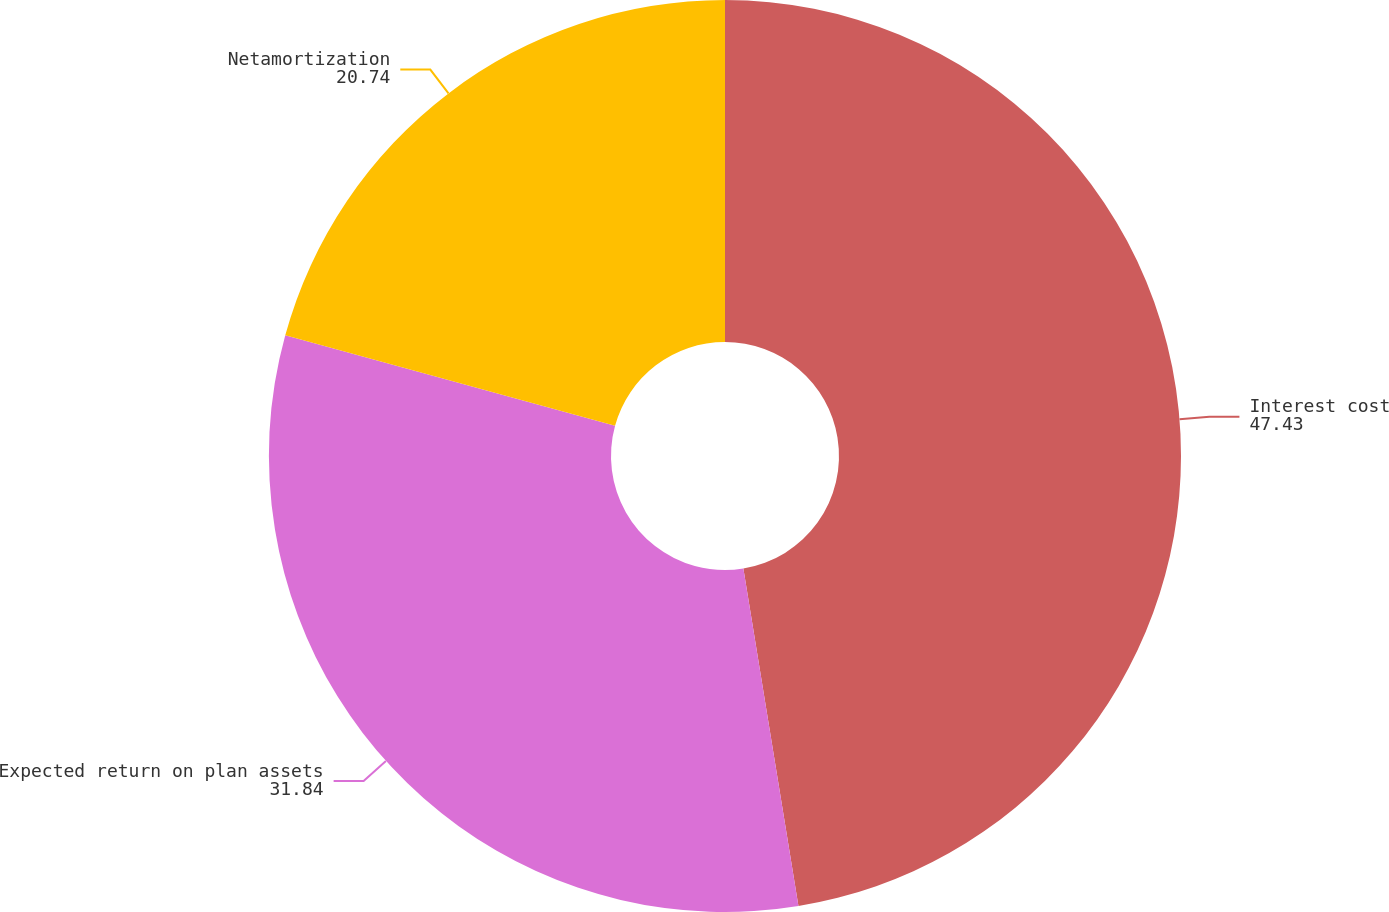<chart> <loc_0><loc_0><loc_500><loc_500><pie_chart><fcel>Interest cost<fcel>Expected return on plan assets<fcel>Netamortization<nl><fcel>47.43%<fcel>31.84%<fcel>20.74%<nl></chart> 